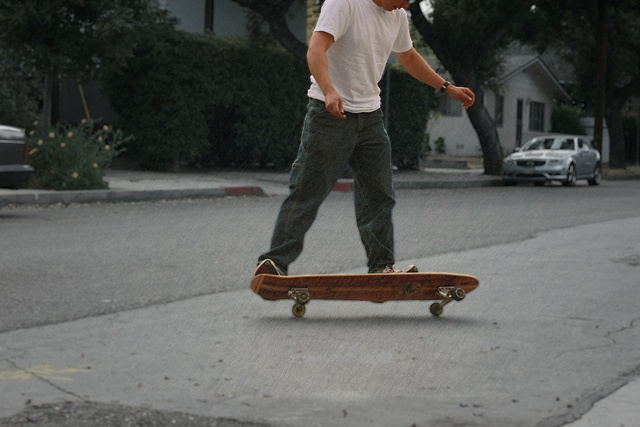Describe the objects in this image and their specific colors. I can see people in black, darkgray, and gray tones, skateboard in black, maroon, and gray tones, car in black, gray, darkgray, and purple tones, and car in black, gray, darkgray, and purple tones in this image. 